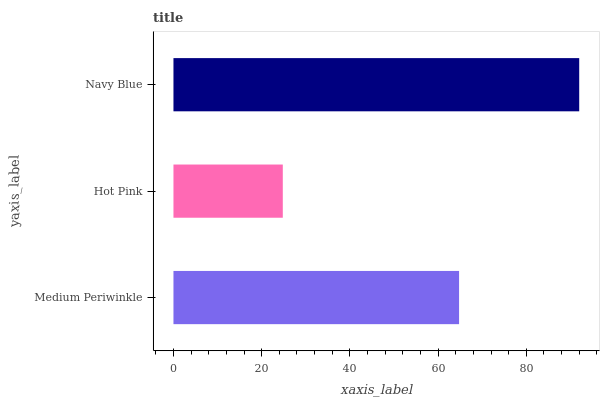Is Hot Pink the minimum?
Answer yes or no. Yes. Is Navy Blue the maximum?
Answer yes or no. Yes. Is Navy Blue the minimum?
Answer yes or no. No. Is Hot Pink the maximum?
Answer yes or no. No. Is Navy Blue greater than Hot Pink?
Answer yes or no. Yes. Is Hot Pink less than Navy Blue?
Answer yes or no. Yes. Is Hot Pink greater than Navy Blue?
Answer yes or no. No. Is Navy Blue less than Hot Pink?
Answer yes or no. No. Is Medium Periwinkle the high median?
Answer yes or no. Yes. Is Medium Periwinkle the low median?
Answer yes or no. Yes. Is Hot Pink the high median?
Answer yes or no. No. Is Navy Blue the low median?
Answer yes or no. No. 